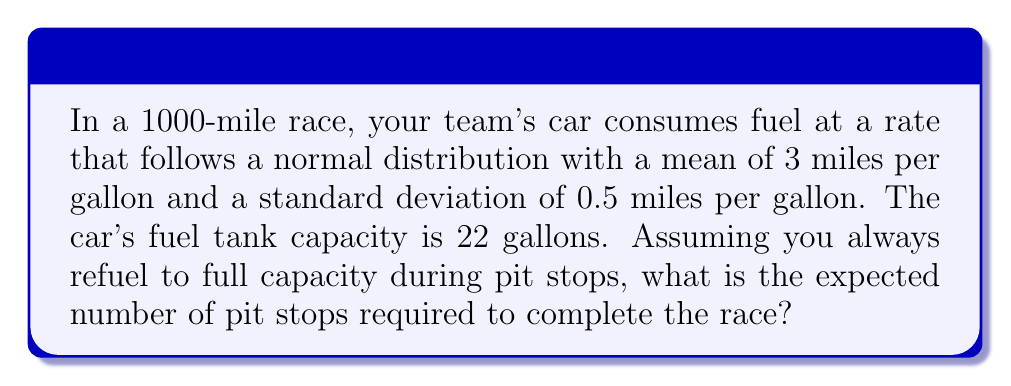Give your solution to this math problem. Let's approach this step-by-step:

1) First, we need to calculate the expected distance the car can travel on a full tank:
   $$ E[\text{Distance}] = \text{Tank Capacity} \times E[\text{Miles per Gallon}] $$
   $$ E[\text{Distance}] = 22 \times 3 = 66 \text{ miles} $$

2) Now, we can calculate the expected number of pit stops:
   $$ E[\text{Pit Stops}] = \frac{\text{Total Race Distance}}{E[\text{Distance per Tank}]} - 1 $$
   
   We subtract 1 because the car starts with a full tank.

3) Plugging in our values:
   $$ E[\text{Pit Stops}] = \frac{1000}{66} - 1 \approx 14.15 $$

4) However, we can't have a fractional number of pit stops. We need to round up to the nearest whole number because we can't complete the race without enough fuel.

5) Therefore, the expected number of pit stops is 15.

Note: This calculation doesn't account for the variability in fuel consumption. In a real race strategy, you might want to consider the probability of running out of fuel before the next planned pit stop, which would involve using the normal distribution properties of the fuel consumption rate.
Answer: 15 pit stops 